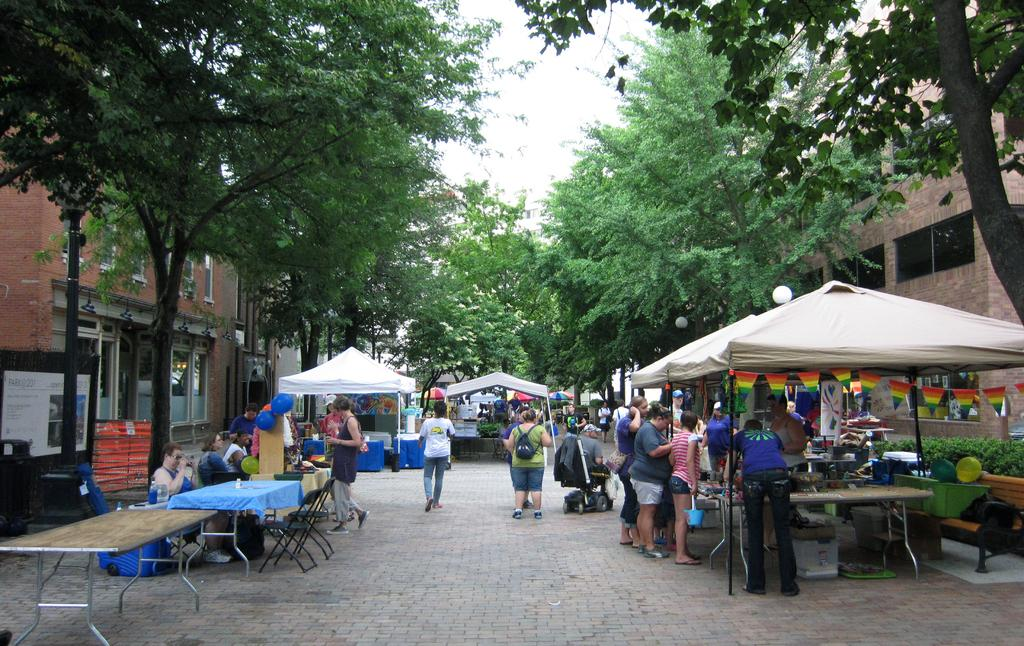What are the people in the image doing? The persons standing on the road are likely waiting or walking. What objects can be seen in the image besides the people? There are tables, trees, and a building visible in the image. What is the background of the image? The sky is visible in the image, providing a background. What type of coach can be seen in the middle of the image? There is no coach present in the image; it features people, tables, trees, a building, and the sky. What is the glue used for in the image? There is no glue present in the image, as it is a scene with people, tables, trees, a building, and the sky. 